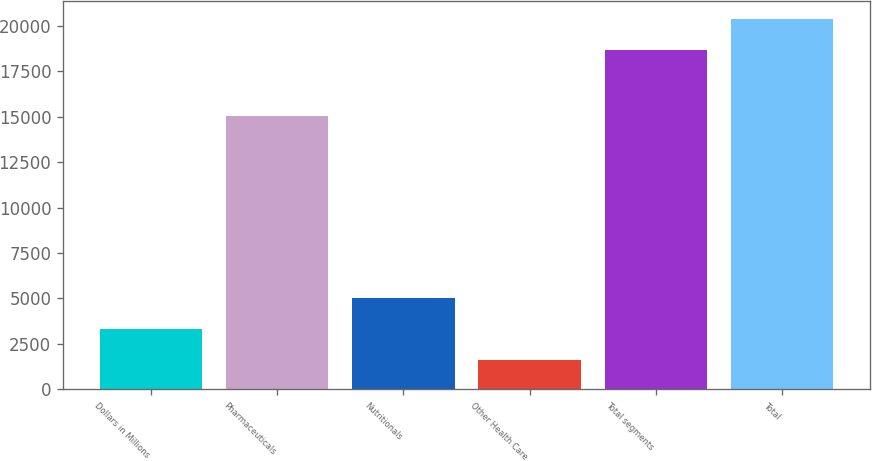<chart> <loc_0><loc_0><loc_500><loc_500><bar_chart><fcel>Dollars in Millions<fcel>Pharmaceuticals<fcel>Nutritionals<fcel>Other Health Care<fcel>Total segments<fcel>Total<nl><fcel>3309.8<fcel>15025<fcel>5014.6<fcel>1605<fcel>18653<fcel>20357.8<nl></chart> 